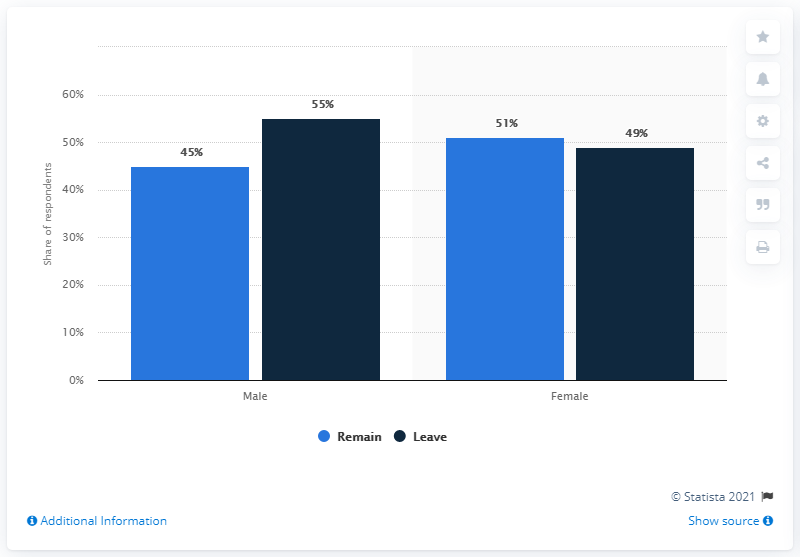Specify some key components in this picture. The value of the rightmost bar is 49. 